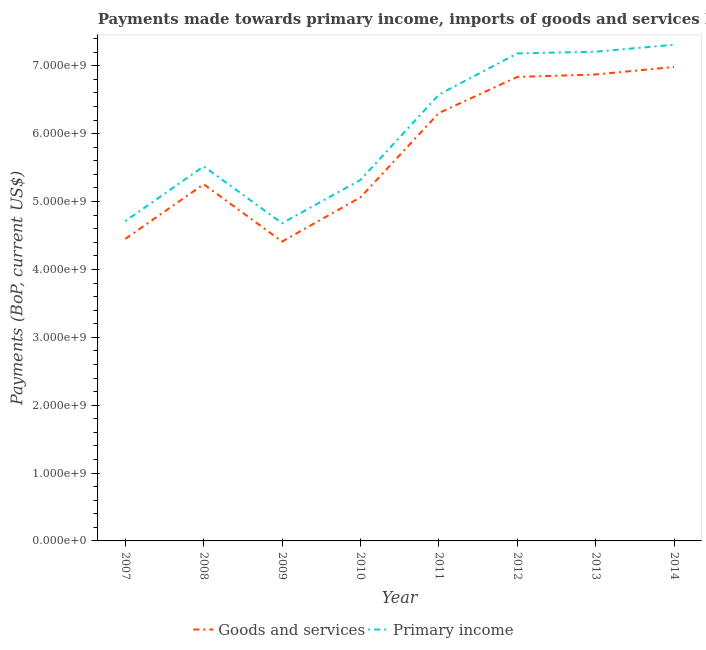Does the line corresponding to payments made towards primary income intersect with the line corresponding to payments made towards goods and services?
Make the answer very short. No. Is the number of lines equal to the number of legend labels?
Offer a very short reply. Yes. What is the payments made towards primary income in 2011?
Your answer should be compact. 6.58e+09. Across all years, what is the maximum payments made towards goods and services?
Your response must be concise. 6.98e+09. Across all years, what is the minimum payments made towards goods and services?
Make the answer very short. 4.41e+09. What is the total payments made towards goods and services in the graph?
Your response must be concise. 4.62e+1. What is the difference between the payments made towards goods and services in 2013 and that in 2014?
Keep it short and to the point. -1.11e+08. What is the difference between the payments made towards goods and services in 2011 and the payments made towards primary income in 2012?
Keep it short and to the point. -8.78e+08. What is the average payments made towards goods and services per year?
Ensure brevity in your answer.  5.77e+09. In the year 2009, what is the difference between the payments made towards primary income and payments made towards goods and services?
Offer a terse response. 2.70e+08. What is the ratio of the payments made towards primary income in 2008 to that in 2013?
Offer a very short reply. 0.77. Is the difference between the payments made towards goods and services in 2012 and 2014 greater than the difference between the payments made towards primary income in 2012 and 2014?
Ensure brevity in your answer.  No. What is the difference between the highest and the second highest payments made towards goods and services?
Your answer should be very brief. 1.11e+08. What is the difference between the highest and the lowest payments made towards primary income?
Offer a terse response. 2.63e+09. Is the payments made towards goods and services strictly greater than the payments made towards primary income over the years?
Your answer should be very brief. No. How many years are there in the graph?
Make the answer very short. 8. What is the difference between two consecutive major ticks on the Y-axis?
Provide a short and direct response. 1.00e+09. Are the values on the major ticks of Y-axis written in scientific E-notation?
Your response must be concise. Yes. Where does the legend appear in the graph?
Your answer should be compact. Bottom center. How many legend labels are there?
Offer a very short reply. 2. What is the title of the graph?
Give a very brief answer. Payments made towards primary income, imports of goods and services by Nicaragua. Does "Age 15+" appear as one of the legend labels in the graph?
Offer a terse response. No. What is the label or title of the Y-axis?
Make the answer very short. Payments (BoP, current US$). What is the Payments (BoP, current US$) of Goods and services in 2007?
Give a very brief answer. 4.45e+09. What is the Payments (BoP, current US$) in Primary income in 2007?
Give a very brief answer. 4.71e+09. What is the Payments (BoP, current US$) of Goods and services in 2008?
Ensure brevity in your answer.  5.26e+09. What is the Payments (BoP, current US$) in Primary income in 2008?
Provide a short and direct response. 5.52e+09. What is the Payments (BoP, current US$) in Goods and services in 2009?
Your answer should be compact. 4.41e+09. What is the Payments (BoP, current US$) in Primary income in 2009?
Ensure brevity in your answer.  4.68e+09. What is the Payments (BoP, current US$) in Goods and services in 2010?
Offer a terse response. 5.06e+09. What is the Payments (BoP, current US$) of Primary income in 2010?
Provide a succinct answer. 5.32e+09. What is the Payments (BoP, current US$) of Goods and services in 2011?
Make the answer very short. 6.30e+09. What is the Payments (BoP, current US$) of Primary income in 2011?
Offer a terse response. 6.58e+09. What is the Payments (BoP, current US$) of Goods and services in 2012?
Ensure brevity in your answer.  6.84e+09. What is the Payments (BoP, current US$) of Primary income in 2012?
Make the answer very short. 7.18e+09. What is the Payments (BoP, current US$) in Goods and services in 2013?
Offer a very short reply. 6.87e+09. What is the Payments (BoP, current US$) in Primary income in 2013?
Ensure brevity in your answer.  7.21e+09. What is the Payments (BoP, current US$) of Goods and services in 2014?
Give a very brief answer. 6.98e+09. What is the Payments (BoP, current US$) of Primary income in 2014?
Offer a very short reply. 7.31e+09. Across all years, what is the maximum Payments (BoP, current US$) in Goods and services?
Provide a short and direct response. 6.98e+09. Across all years, what is the maximum Payments (BoP, current US$) in Primary income?
Ensure brevity in your answer.  7.31e+09. Across all years, what is the minimum Payments (BoP, current US$) of Goods and services?
Provide a short and direct response. 4.41e+09. Across all years, what is the minimum Payments (BoP, current US$) of Primary income?
Keep it short and to the point. 4.68e+09. What is the total Payments (BoP, current US$) in Goods and services in the graph?
Offer a very short reply. 4.62e+1. What is the total Payments (BoP, current US$) of Primary income in the graph?
Provide a short and direct response. 4.85e+1. What is the difference between the Payments (BoP, current US$) of Goods and services in 2007 and that in 2008?
Provide a short and direct response. -8.05e+08. What is the difference between the Payments (BoP, current US$) in Primary income in 2007 and that in 2008?
Keep it short and to the point. -8.07e+08. What is the difference between the Payments (BoP, current US$) of Goods and services in 2007 and that in 2009?
Provide a succinct answer. 3.97e+07. What is the difference between the Payments (BoP, current US$) in Primary income in 2007 and that in 2009?
Your answer should be very brief. 3.12e+07. What is the difference between the Payments (BoP, current US$) in Goods and services in 2007 and that in 2010?
Ensure brevity in your answer.  -6.12e+08. What is the difference between the Payments (BoP, current US$) in Primary income in 2007 and that in 2010?
Your response must be concise. -6.07e+08. What is the difference between the Payments (BoP, current US$) in Goods and services in 2007 and that in 2011?
Your answer should be very brief. -1.85e+09. What is the difference between the Payments (BoP, current US$) in Primary income in 2007 and that in 2011?
Offer a very short reply. -1.86e+09. What is the difference between the Payments (BoP, current US$) of Goods and services in 2007 and that in 2012?
Your response must be concise. -2.39e+09. What is the difference between the Payments (BoP, current US$) in Primary income in 2007 and that in 2012?
Give a very brief answer. -2.47e+09. What is the difference between the Payments (BoP, current US$) of Goods and services in 2007 and that in 2013?
Your answer should be very brief. -2.42e+09. What is the difference between the Payments (BoP, current US$) of Primary income in 2007 and that in 2013?
Your answer should be very brief. -2.50e+09. What is the difference between the Payments (BoP, current US$) of Goods and services in 2007 and that in 2014?
Offer a terse response. -2.53e+09. What is the difference between the Payments (BoP, current US$) in Primary income in 2007 and that in 2014?
Make the answer very short. -2.60e+09. What is the difference between the Payments (BoP, current US$) of Goods and services in 2008 and that in 2009?
Ensure brevity in your answer.  8.44e+08. What is the difference between the Payments (BoP, current US$) in Primary income in 2008 and that in 2009?
Ensure brevity in your answer.  8.38e+08. What is the difference between the Payments (BoP, current US$) of Goods and services in 2008 and that in 2010?
Give a very brief answer. 1.92e+08. What is the difference between the Payments (BoP, current US$) in Primary income in 2008 and that in 2010?
Your answer should be compact. 2.00e+08. What is the difference between the Payments (BoP, current US$) of Goods and services in 2008 and that in 2011?
Provide a succinct answer. -1.05e+09. What is the difference between the Payments (BoP, current US$) in Primary income in 2008 and that in 2011?
Your answer should be compact. -1.06e+09. What is the difference between the Payments (BoP, current US$) of Goods and services in 2008 and that in 2012?
Your answer should be very brief. -1.58e+09. What is the difference between the Payments (BoP, current US$) in Primary income in 2008 and that in 2012?
Your answer should be compact. -1.66e+09. What is the difference between the Payments (BoP, current US$) of Goods and services in 2008 and that in 2013?
Offer a very short reply. -1.62e+09. What is the difference between the Payments (BoP, current US$) of Primary income in 2008 and that in 2013?
Offer a very short reply. -1.69e+09. What is the difference between the Payments (BoP, current US$) of Goods and services in 2008 and that in 2014?
Give a very brief answer. -1.73e+09. What is the difference between the Payments (BoP, current US$) of Primary income in 2008 and that in 2014?
Provide a succinct answer. -1.79e+09. What is the difference between the Payments (BoP, current US$) of Goods and services in 2009 and that in 2010?
Your answer should be very brief. -6.52e+08. What is the difference between the Payments (BoP, current US$) of Primary income in 2009 and that in 2010?
Your answer should be very brief. -6.38e+08. What is the difference between the Payments (BoP, current US$) of Goods and services in 2009 and that in 2011?
Ensure brevity in your answer.  -1.89e+09. What is the difference between the Payments (BoP, current US$) in Primary income in 2009 and that in 2011?
Provide a succinct answer. -1.90e+09. What is the difference between the Payments (BoP, current US$) in Goods and services in 2009 and that in 2012?
Keep it short and to the point. -2.43e+09. What is the difference between the Payments (BoP, current US$) in Primary income in 2009 and that in 2012?
Your answer should be compact. -2.50e+09. What is the difference between the Payments (BoP, current US$) in Goods and services in 2009 and that in 2013?
Give a very brief answer. -2.46e+09. What is the difference between the Payments (BoP, current US$) of Primary income in 2009 and that in 2013?
Your answer should be compact. -2.53e+09. What is the difference between the Payments (BoP, current US$) of Goods and services in 2009 and that in 2014?
Provide a succinct answer. -2.57e+09. What is the difference between the Payments (BoP, current US$) of Primary income in 2009 and that in 2014?
Your response must be concise. -2.63e+09. What is the difference between the Payments (BoP, current US$) in Goods and services in 2010 and that in 2011?
Provide a succinct answer. -1.24e+09. What is the difference between the Payments (BoP, current US$) of Primary income in 2010 and that in 2011?
Your response must be concise. -1.26e+09. What is the difference between the Payments (BoP, current US$) of Goods and services in 2010 and that in 2012?
Offer a terse response. -1.77e+09. What is the difference between the Payments (BoP, current US$) in Primary income in 2010 and that in 2012?
Your answer should be very brief. -1.86e+09. What is the difference between the Payments (BoP, current US$) of Goods and services in 2010 and that in 2013?
Your answer should be compact. -1.81e+09. What is the difference between the Payments (BoP, current US$) of Primary income in 2010 and that in 2013?
Your answer should be compact. -1.89e+09. What is the difference between the Payments (BoP, current US$) of Goods and services in 2010 and that in 2014?
Provide a succinct answer. -1.92e+09. What is the difference between the Payments (BoP, current US$) in Primary income in 2010 and that in 2014?
Give a very brief answer. -1.99e+09. What is the difference between the Payments (BoP, current US$) of Goods and services in 2011 and that in 2012?
Offer a terse response. -5.32e+08. What is the difference between the Payments (BoP, current US$) in Primary income in 2011 and that in 2012?
Keep it short and to the point. -6.07e+08. What is the difference between the Payments (BoP, current US$) in Goods and services in 2011 and that in 2013?
Make the answer very short. -5.68e+08. What is the difference between the Payments (BoP, current US$) of Primary income in 2011 and that in 2013?
Offer a terse response. -6.32e+08. What is the difference between the Payments (BoP, current US$) in Goods and services in 2011 and that in 2014?
Make the answer very short. -6.78e+08. What is the difference between the Payments (BoP, current US$) of Primary income in 2011 and that in 2014?
Your answer should be very brief. -7.35e+08. What is the difference between the Payments (BoP, current US$) of Goods and services in 2012 and that in 2013?
Ensure brevity in your answer.  -3.58e+07. What is the difference between the Payments (BoP, current US$) in Primary income in 2012 and that in 2013?
Keep it short and to the point. -2.56e+07. What is the difference between the Payments (BoP, current US$) of Goods and services in 2012 and that in 2014?
Provide a succinct answer. -1.47e+08. What is the difference between the Payments (BoP, current US$) in Primary income in 2012 and that in 2014?
Keep it short and to the point. -1.28e+08. What is the difference between the Payments (BoP, current US$) in Goods and services in 2013 and that in 2014?
Keep it short and to the point. -1.11e+08. What is the difference between the Payments (BoP, current US$) of Primary income in 2013 and that in 2014?
Give a very brief answer. -1.03e+08. What is the difference between the Payments (BoP, current US$) in Goods and services in 2007 and the Payments (BoP, current US$) in Primary income in 2008?
Give a very brief answer. -1.07e+09. What is the difference between the Payments (BoP, current US$) in Goods and services in 2007 and the Payments (BoP, current US$) in Primary income in 2009?
Provide a short and direct response. -2.30e+08. What is the difference between the Payments (BoP, current US$) in Goods and services in 2007 and the Payments (BoP, current US$) in Primary income in 2010?
Keep it short and to the point. -8.69e+08. What is the difference between the Payments (BoP, current US$) in Goods and services in 2007 and the Payments (BoP, current US$) in Primary income in 2011?
Make the answer very short. -2.13e+09. What is the difference between the Payments (BoP, current US$) of Goods and services in 2007 and the Payments (BoP, current US$) of Primary income in 2012?
Your answer should be very brief. -2.73e+09. What is the difference between the Payments (BoP, current US$) in Goods and services in 2007 and the Payments (BoP, current US$) in Primary income in 2013?
Offer a very short reply. -2.76e+09. What is the difference between the Payments (BoP, current US$) of Goods and services in 2007 and the Payments (BoP, current US$) of Primary income in 2014?
Your answer should be very brief. -2.86e+09. What is the difference between the Payments (BoP, current US$) in Goods and services in 2008 and the Payments (BoP, current US$) in Primary income in 2009?
Keep it short and to the point. 5.74e+08. What is the difference between the Payments (BoP, current US$) of Goods and services in 2008 and the Payments (BoP, current US$) of Primary income in 2010?
Provide a succinct answer. -6.41e+07. What is the difference between the Payments (BoP, current US$) in Goods and services in 2008 and the Payments (BoP, current US$) in Primary income in 2011?
Offer a very short reply. -1.32e+09. What is the difference between the Payments (BoP, current US$) in Goods and services in 2008 and the Payments (BoP, current US$) in Primary income in 2012?
Your response must be concise. -1.93e+09. What is the difference between the Payments (BoP, current US$) of Goods and services in 2008 and the Payments (BoP, current US$) of Primary income in 2013?
Provide a short and direct response. -1.95e+09. What is the difference between the Payments (BoP, current US$) of Goods and services in 2008 and the Payments (BoP, current US$) of Primary income in 2014?
Offer a terse response. -2.06e+09. What is the difference between the Payments (BoP, current US$) of Goods and services in 2009 and the Payments (BoP, current US$) of Primary income in 2010?
Ensure brevity in your answer.  -9.08e+08. What is the difference between the Payments (BoP, current US$) of Goods and services in 2009 and the Payments (BoP, current US$) of Primary income in 2011?
Make the answer very short. -2.17e+09. What is the difference between the Payments (BoP, current US$) of Goods and services in 2009 and the Payments (BoP, current US$) of Primary income in 2012?
Keep it short and to the point. -2.77e+09. What is the difference between the Payments (BoP, current US$) in Goods and services in 2009 and the Payments (BoP, current US$) in Primary income in 2013?
Provide a succinct answer. -2.80e+09. What is the difference between the Payments (BoP, current US$) of Goods and services in 2009 and the Payments (BoP, current US$) of Primary income in 2014?
Your answer should be compact. -2.90e+09. What is the difference between the Payments (BoP, current US$) of Goods and services in 2010 and the Payments (BoP, current US$) of Primary income in 2011?
Make the answer very short. -1.51e+09. What is the difference between the Payments (BoP, current US$) in Goods and services in 2010 and the Payments (BoP, current US$) in Primary income in 2012?
Make the answer very short. -2.12e+09. What is the difference between the Payments (BoP, current US$) in Goods and services in 2010 and the Payments (BoP, current US$) in Primary income in 2013?
Your response must be concise. -2.15e+09. What is the difference between the Payments (BoP, current US$) of Goods and services in 2010 and the Payments (BoP, current US$) of Primary income in 2014?
Provide a succinct answer. -2.25e+09. What is the difference between the Payments (BoP, current US$) of Goods and services in 2011 and the Payments (BoP, current US$) of Primary income in 2012?
Ensure brevity in your answer.  -8.78e+08. What is the difference between the Payments (BoP, current US$) of Goods and services in 2011 and the Payments (BoP, current US$) of Primary income in 2013?
Keep it short and to the point. -9.03e+08. What is the difference between the Payments (BoP, current US$) in Goods and services in 2011 and the Payments (BoP, current US$) in Primary income in 2014?
Offer a very short reply. -1.01e+09. What is the difference between the Payments (BoP, current US$) in Goods and services in 2012 and the Payments (BoP, current US$) in Primary income in 2013?
Offer a terse response. -3.72e+08. What is the difference between the Payments (BoP, current US$) of Goods and services in 2012 and the Payments (BoP, current US$) of Primary income in 2014?
Give a very brief answer. -4.74e+08. What is the difference between the Payments (BoP, current US$) in Goods and services in 2013 and the Payments (BoP, current US$) in Primary income in 2014?
Provide a short and direct response. -4.39e+08. What is the average Payments (BoP, current US$) in Goods and services per year?
Provide a short and direct response. 5.77e+09. What is the average Payments (BoP, current US$) in Primary income per year?
Provide a short and direct response. 6.06e+09. In the year 2007, what is the difference between the Payments (BoP, current US$) of Goods and services and Payments (BoP, current US$) of Primary income?
Provide a short and direct response. -2.61e+08. In the year 2008, what is the difference between the Payments (BoP, current US$) of Goods and services and Payments (BoP, current US$) of Primary income?
Offer a terse response. -2.64e+08. In the year 2009, what is the difference between the Payments (BoP, current US$) in Goods and services and Payments (BoP, current US$) in Primary income?
Your response must be concise. -2.70e+08. In the year 2010, what is the difference between the Payments (BoP, current US$) in Goods and services and Payments (BoP, current US$) in Primary income?
Your answer should be very brief. -2.57e+08. In the year 2011, what is the difference between the Payments (BoP, current US$) in Goods and services and Payments (BoP, current US$) in Primary income?
Your response must be concise. -2.71e+08. In the year 2012, what is the difference between the Payments (BoP, current US$) of Goods and services and Payments (BoP, current US$) of Primary income?
Offer a very short reply. -3.46e+08. In the year 2013, what is the difference between the Payments (BoP, current US$) of Goods and services and Payments (BoP, current US$) of Primary income?
Keep it short and to the point. -3.36e+08. In the year 2014, what is the difference between the Payments (BoP, current US$) of Goods and services and Payments (BoP, current US$) of Primary income?
Offer a terse response. -3.28e+08. What is the ratio of the Payments (BoP, current US$) in Goods and services in 2007 to that in 2008?
Your answer should be very brief. 0.85. What is the ratio of the Payments (BoP, current US$) of Primary income in 2007 to that in 2008?
Keep it short and to the point. 0.85. What is the ratio of the Payments (BoP, current US$) of Goods and services in 2007 to that in 2009?
Offer a very short reply. 1.01. What is the ratio of the Payments (BoP, current US$) of Primary income in 2007 to that in 2009?
Keep it short and to the point. 1.01. What is the ratio of the Payments (BoP, current US$) in Goods and services in 2007 to that in 2010?
Make the answer very short. 0.88. What is the ratio of the Payments (BoP, current US$) in Primary income in 2007 to that in 2010?
Your response must be concise. 0.89. What is the ratio of the Payments (BoP, current US$) in Goods and services in 2007 to that in 2011?
Offer a very short reply. 0.71. What is the ratio of the Payments (BoP, current US$) of Primary income in 2007 to that in 2011?
Your answer should be very brief. 0.72. What is the ratio of the Payments (BoP, current US$) of Goods and services in 2007 to that in 2012?
Keep it short and to the point. 0.65. What is the ratio of the Payments (BoP, current US$) in Primary income in 2007 to that in 2012?
Offer a very short reply. 0.66. What is the ratio of the Payments (BoP, current US$) in Goods and services in 2007 to that in 2013?
Your response must be concise. 0.65. What is the ratio of the Payments (BoP, current US$) in Primary income in 2007 to that in 2013?
Ensure brevity in your answer.  0.65. What is the ratio of the Payments (BoP, current US$) of Goods and services in 2007 to that in 2014?
Your answer should be very brief. 0.64. What is the ratio of the Payments (BoP, current US$) in Primary income in 2007 to that in 2014?
Keep it short and to the point. 0.64. What is the ratio of the Payments (BoP, current US$) of Goods and services in 2008 to that in 2009?
Give a very brief answer. 1.19. What is the ratio of the Payments (BoP, current US$) in Primary income in 2008 to that in 2009?
Offer a very short reply. 1.18. What is the ratio of the Payments (BoP, current US$) of Goods and services in 2008 to that in 2010?
Keep it short and to the point. 1.04. What is the ratio of the Payments (BoP, current US$) in Primary income in 2008 to that in 2010?
Ensure brevity in your answer.  1.04. What is the ratio of the Payments (BoP, current US$) in Goods and services in 2008 to that in 2011?
Your answer should be compact. 0.83. What is the ratio of the Payments (BoP, current US$) in Primary income in 2008 to that in 2011?
Your response must be concise. 0.84. What is the ratio of the Payments (BoP, current US$) of Goods and services in 2008 to that in 2012?
Your response must be concise. 0.77. What is the ratio of the Payments (BoP, current US$) in Primary income in 2008 to that in 2012?
Your response must be concise. 0.77. What is the ratio of the Payments (BoP, current US$) of Goods and services in 2008 to that in 2013?
Your answer should be compact. 0.76. What is the ratio of the Payments (BoP, current US$) in Primary income in 2008 to that in 2013?
Keep it short and to the point. 0.77. What is the ratio of the Payments (BoP, current US$) in Goods and services in 2008 to that in 2014?
Keep it short and to the point. 0.75. What is the ratio of the Payments (BoP, current US$) of Primary income in 2008 to that in 2014?
Ensure brevity in your answer.  0.75. What is the ratio of the Payments (BoP, current US$) of Goods and services in 2009 to that in 2010?
Offer a very short reply. 0.87. What is the ratio of the Payments (BoP, current US$) of Goods and services in 2009 to that in 2011?
Your answer should be very brief. 0.7. What is the ratio of the Payments (BoP, current US$) in Primary income in 2009 to that in 2011?
Provide a short and direct response. 0.71. What is the ratio of the Payments (BoP, current US$) in Goods and services in 2009 to that in 2012?
Your response must be concise. 0.65. What is the ratio of the Payments (BoP, current US$) in Primary income in 2009 to that in 2012?
Your answer should be very brief. 0.65. What is the ratio of the Payments (BoP, current US$) in Goods and services in 2009 to that in 2013?
Keep it short and to the point. 0.64. What is the ratio of the Payments (BoP, current US$) of Primary income in 2009 to that in 2013?
Your answer should be very brief. 0.65. What is the ratio of the Payments (BoP, current US$) in Goods and services in 2009 to that in 2014?
Offer a terse response. 0.63. What is the ratio of the Payments (BoP, current US$) in Primary income in 2009 to that in 2014?
Your answer should be compact. 0.64. What is the ratio of the Payments (BoP, current US$) in Goods and services in 2010 to that in 2011?
Provide a short and direct response. 0.8. What is the ratio of the Payments (BoP, current US$) in Primary income in 2010 to that in 2011?
Your answer should be very brief. 0.81. What is the ratio of the Payments (BoP, current US$) of Goods and services in 2010 to that in 2012?
Provide a succinct answer. 0.74. What is the ratio of the Payments (BoP, current US$) in Primary income in 2010 to that in 2012?
Provide a succinct answer. 0.74. What is the ratio of the Payments (BoP, current US$) of Goods and services in 2010 to that in 2013?
Ensure brevity in your answer.  0.74. What is the ratio of the Payments (BoP, current US$) of Primary income in 2010 to that in 2013?
Give a very brief answer. 0.74. What is the ratio of the Payments (BoP, current US$) in Goods and services in 2010 to that in 2014?
Give a very brief answer. 0.72. What is the ratio of the Payments (BoP, current US$) of Primary income in 2010 to that in 2014?
Give a very brief answer. 0.73. What is the ratio of the Payments (BoP, current US$) of Goods and services in 2011 to that in 2012?
Your answer should be very brief. 0.92. What is the ratio of the Payments (BoP, current US$) in Primary income in 2011 to that in 2012?
Your answer should be compact. 0.92. What is the ratio of the Payments (BoP, current US$) in Goods and services in 2011 to that in 2013?
Provide a succinct answer. 0.92. What is the ratio of the Payments (BoP, current US$) in Primary income in 2011 to that in 2013?
Provide a short and direct response. 0.91. What is the ratio of the Payments (BoP, current US$) of Goods and services in 2011 to that in 2014?
Give a very brief answer. 0.9. What is the ratio of the Payments (BoP, current US$) in Primary income in 2011 to that in 2014?
Make the answer very short. 0.9. What is the ratio of the Payments (BoP, current US$) of Goods and services in 2012 to that in 2013?
Provide a short and direct response. 0.99. What is the ratio of the Payments (BoP, current US$) of Goods and services in 2012 to that in 2014?
Provide a short and direct response. 0.98. What is the ratio of the Payments (BoP, current US$) in Primary income in 2012 to that in 2014?
Your response must be concise. 0.98. What is the ratio of the Payments (BoP, current US$) in Goods and services in 2013 to that in 2014?
Offer a terse response. 0.98. What is the ratio of the Payments (BoP, current US$) of Primary income in 2013 to that in 2014?
Give a very brief answer. 0.99. What is the difference between the highest and the second highest Payments (BoP, current US$) of Goods and services?
Your answer should be very brief. 1.11e+08. What is the difference between the highest and the second highest Payments (BoP, current US$) of Primary income?
Your answer should be compact. 1.03e+08. What is the difference between the highest and the lowest Payments (BoP, current US$) in Goods and services?
Offer a very short reply. 2.57e+09. What is the difference between the highest and the lowest Payments (BoP, current US$) in Primary income?
Keep it short and to the point. 2.63e+09. 